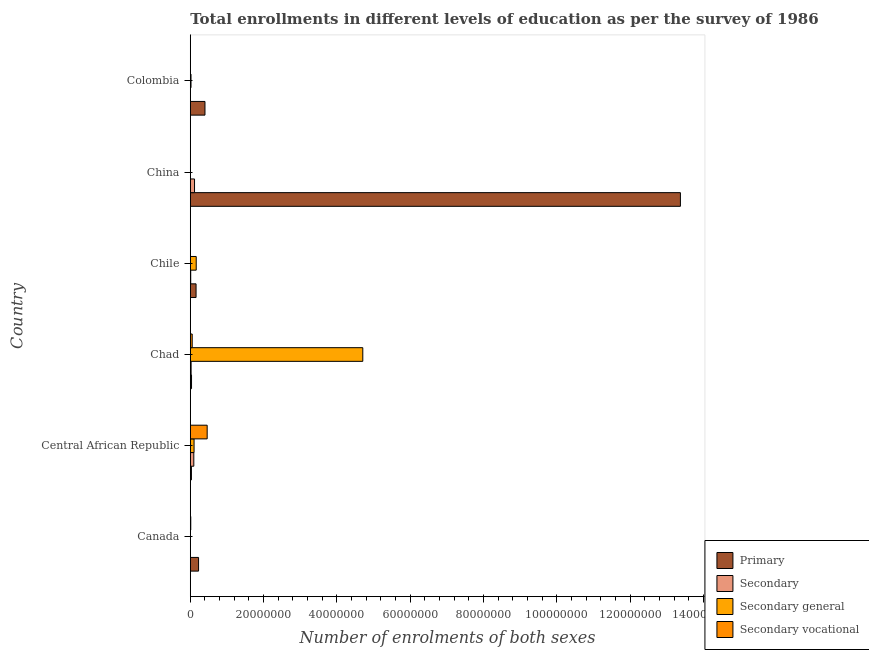How many groups of bars are there?
Keep it short and to the point. 6. Are the number of bars per tick equal to the number of legend labels?
Keep it short and to the point. Yes. How many bars are there on the 2nd tick from the top?
Provide a short and direct response. 4. What is the label of the 4th group of bars from the top?
Keep it short and to the point. Chad. What is the number of enrolments in primary education in Canada?
Make the answer very short. 2.25e+06. Across all countries, what is the maximum number of enrolments in secondary vocational education?
Your answer should be very brief. 4.60e+06. Across all countries, what is the minimum number of enrolments in secondary education?
Your answer should be compact. 2.11e+04. In which country was the number of enrolments in secondary general education maximum?
Keep it short and to the point. Chad. In which country was the number of enrolments in primary education minimum?
Offer a very short reply. Central African Republic. What is the total number of enrolments in secondary vocational education in the graph?
Ensure brevity in your answer.  5.30e+06. What is the difference between the number of enrolments in secondary vocational education in Chad and that in Chile?
Make the answer very short. 5.18e+05. What is the difference between the number of enrolments in secondary general education in Canada and the number of enrolments in secondary vocational education in Chad?
Provide a short and direct response. -4.62e+05. What is the average number of enrolments in secondary education per country?
Offer a terse response. 4.20e+05. What is the difference between the number of enrolments in secondary vocational education and number of enrolments in primary education in Canada?
Keep it short and to the point. -2.13e+06. In how many countries, is the number of enrolments in secondary vocational education greater than 48000000 ?
Offer a terse response. 0. What is the ratio of the number of enrolments in primary education in Canada to that in Chile?
Your answer should be very brief. 1.43. Is the difference between the number of enrolments in secondary education in China and Colombia greater than the difference between the number of enrolments in primary education in China and Colombia?
Provide a succinct answer. No. What is the difference between the highest and the second highest number of enrolments in secondary general education?
Ensure brevity in your answer.  4.54e+07. What is the difference between the highest and the lowest number of enrolments in secondary vocational education?
Your response must be concise. 4.60e+06. What does the 1st bar from the top in China represents?
Your answer should be compact. Secondary vocational. What does the 1st bar from the bottom in Colombia represents?
Your response must be concise. Primary. Is it the case that in every country, the sum of the number of enrolments in primary education and number of enrolments in secondary education is greater than the number of enrolments in secondary general education?
Your response must be concise. No. How many bars are there?
Offer a very short reply. 24. Are all the bars in the graph horizontal?
Offer a terse response. Yes. What is the difference between two consecutive major ticks on the X-axis?
Provide a succinct answer. 2.00e+07. Are the values on the major ticks of X-axis written in scientific E-notation?
Ensure brevity in your answer.  No. Does the graph contain any zero values?
Provide a short and direct response. No. Where does the legend appear in the graph?
Give a very brief answer. Bottom right. What is the title of the graph?
Ensure brevity in your answer.  Total enrollments in different levels of education as per the survey of 1986. Does "Argument" appear as one of the legend labels in the graph?
Your answer should be compact. No. What is the label or title of the X-axis?
Your answer should be compact. Number of enrolments of both sexes. What is the label or title of the Y-axis?
Offer a very short reply. Country. What is the Number of enrolments of both sexes of Primary in Canada?
Provide a short and direct response. 2.25e+06. What is the Number of enrolments of both sexes of Secondary in Canada?
Your response must be concise. 2.11e+04. What is the Number of enrolments of both sexes in Secondary general in Canada?
Your response must be concise. 5.69e+04. What is the Number of enrolments of both sexes in Secondary vocational in Canada?
Provide a succinct answer. 1.27e+05. What is the Number of enrolments of both sexes of Primary in Central African Republic?
Provide a succinct answer. 3.10e+05. What is the Number of enrolments of both sexes of Secondary in Central African Republic?
Ensure brevity in your answer.  9.60e+05. What is the Number of enrolments of both sexes in Secondary general in Central African Republic?
Your response must be concise. 1.03e+06. What is the Number of enrolments of both sexes in Secondary vocational in Central African Republic?
Offer a terse response. 4.60e+06. What is the Number of enrolments of both sexes of Primary in Chad?
Your answer should be compact. 3.38e+05. What is the Number of enrolments of both sexes of Secondary in Chad?
Ensure brevity in your answer.  2.23e+05. What is the Number of enrolments of both sexes in Secondary general in Chad?
Ensure brevity in your answer.  4.71e+07. What is the Number of enrolments of both sexes in Secondary vocational in Chad?
Provide a short and direct response. 5.19e+05. What is the Number of enrolments of both sexes of Primary in Chile?
Keep it short and to the point. 1.57e+06. What is the Number of enrolments of both sexes of Secondary in Chile?
Your response must be concise. 1.15e+05. What is the Number of enrolments of both sexes in Secondary general in Chile?
Give a very brief answer. 1.62e+06. What is the Number of enrolments of both sexes in Secondary vocational in Chile?
Provide a succinct answer. 515. What is the Number of enrolments of both sexes in Primary in China?
Ensure brevity in your answer.  1.34e+08. What is the Number of enrolments of both sexes in Secondary in China?
Provide a short and direct response. 1.16e+06. What is the Number of enrolments of both sexes in Secondary general in China?
Keep it short and to the point. 2.05e+04. What is the Number of enrolments of both sexes of Secondary vocational in China?
Provide a succinct answer. 2.51e+04. What is the Number of enrolments of both sexes in Primary in Colombia?
Offer a terse response. 4.00e+06. What is the Number of enrolments of both sexes of Secondary in Colombia?
Offer a terse response. 4.62e+04. What is the Number of enrolments of both sexes in Secondary general in Colombia?
Offer a very short reply. 1.97e+05. What is the Number of enrolments of both sexes of Secondary vocational in Colombia?
Keep it short and to the point. 2.60e+04. Across all countries, what is the maximum Number of enrolments of both sexes in Primary?
Offer a terse response. 1.34e+08. Across all countries, what is the maximum Number of enrolments of both sexes of Secondary?
Offer a very short reply. 1.16e+06. Across all countries, what is the maximum Number of enrolments of both sexes in Secondary general?
Your response must be concise. 4.71e+07. Across all countries, what is the maximum Number of enrolments of both sexes in Secondary vocational?
Your answer should be very brief. 4.60e+06. Across all countries, what is the minimum Number of enrolments of both sexes of Primary?
Keep it short and to the point. 3.10e+05. Across all countries, what is the minimum Number of enrolments of both sexes of Secondary?
Keep it short and to the point. 2.11e+04. Across all countries, what is the minimum Number of enrolments of both sexes of Secondary general?
Your answer should be compact. 2.05e+04. Across all countries, what is the minimum Number of enrolments of both sexes of Secondary vocational?
Keep it short and to the point. 515. What is the total Number of enrolments of both sexes of Primary in the graph?
Keep it short and to the point. 1.42e+08. What is the total Number of enrolments of both sexes in Secondary in the graph?
Make the answer very short. 2.52e+06. What is the total Number of enrolments of both sexes in Secondary general in the graph?
Provide a short and direct response. 5.00e+07. What is the total Number of enrolments of both sexes in Secondary vocational in the graph?
Ensure brevity in your answer.  5.30e+06. What is the difference between the Number of enrolments of both sexes in Primary in Canada and that in Central African Republic?
Make the answer very short. 1.95e+06. What is the difference between the Number of enrolments of both sexes of Secondary in Canada and that in Central African Republic?
Your answer should be compact. -9.39e+05. What is the difference between the Number of enrolments of both sexes in Secondary general in Canada and that in Central African Republic?
Keep it short and to the point. -9.69e+05. What is the difference between the Number of enrolments of both sexes in Secondary vocational in Canada and that in Central African Republic?
Give a very brief answer. -4.48e+06. What is the difference between the Number of enrolments of both sexes in Primary in Canada and that in Chad?
Provide a succinct answer. 1.92e+06. What is the difference between the Number of enrolments of both sexes in Secondary in Canada and that in Chad?
Make the answer very short. -2.02e+05. What is the difference between the Number of enrolments of both sexes in Secondary general in Canada and that in Chad?
Keep it short and to the point. -4.70e+07. What is the difference between the Number of enrolments of both sexes in Secondary vocational in Canada and that in Chad?
Make the answer very short. -3.92e+05. What is the difference between the Number of enrolments of both sexes of Primary in Canada and that in Chile?
Make the answer very short. 6.80e+05. What is the difference between the Number of enrolments of both sexes in Secondary in Canada and that in Chile?
Keep it short and to the point. -9.36e+04. What is the difference between the Number of enrolments of both sexes in Secondary general in Canada and that in Chile?
Your response must be concise. -1.56e+06. What is the difference between the Number of enrolments of both sexes in Secondary vocational in Canada and that in Chile?
Make the answer very short. 1.27e+05. What is the difference between the Number of enrolments of both sexes in Primary in Canada and that in China?
Ensure brevity in your answer.  -1.31e+08. What is the difference between the Number of enrolments of both sexes of Secondary in Canada and that in China?
Offer a very short reply. -1.14e+06. What is the difference between the Number of enrolments of both sexes in Secondary general in Canada and that in China?
Ensure brevity in your answer.  3.64e+04. What is the difference between the Number of enrolments of both sexes in Secondary vocational in Canada and that in China?
Offer a very short reply. 1.02e+05. What is the difference between the Number of enrolments of both sexes in Primary in Canada and that in Colombia?
Provide a short and direct response. -1.75e+06. What is the difference between the Number of enrolments of both sexes of Secondary in Canada and that in Colombia?
Offer a terse response. -2.51e+04. What is the difference between the Number of enrolments of both sexes of Secondary general in Canada and that in Colombia?
Offer a very short reply. -1.41e+05. What is the difference between the Number of enrolments of both sexes of Secondary vocational in Canada and that in Colombia?
Provide a succinct answer. 1.01e+05. What is the difference between the Number of enrolments of both sexes in Primary in Central African Republic and that in Chad?
Give a very brief answer. -2.80e+04. What is the difference between the Number of enrolments of both sexes of Secondary in Central African Republic and that in Chad?
Provide a short and direct response. 7.37e+05. What is the difference between the Number of enrolments of both sexes of Secondary general in Central African Republic and that in Chad?
Make the answer very short. -4.60e+07. What is the difference between the Number of enrolments of both sexes of Secondary vocational in Central African Republic and that in Chad?
Offer a terse response. 4.09e+06. What is the difference between the Number of enrolments of both sexes in Primary in Central African Republic and that in Chile?
Your response must be concise. -1.27e+06. What is the difference between the Number of enrolments of both sexes of Secondary in Central African Republic and that in Chile?
Provide a short and direct response. 8.45e+05. What is the difference between the Number of enrolments of both sexes in Secondary general in Central African Republic and that in Chile?
Provide a short and direct response. -5.91e+05. What is the difference between the Number of enrolments of both sexes of Secondary vocational in Central African Republic and that in Chile?
Your answer should be very brief. 4.60e+06. What is the difference between the Number of enrolments of both sexes of Primary in Central African Republic and that in China?
Offer a terse response. -1.33e+08. What is the difference between the Number of enrolments of both sexes of Secondary in Central African Republic and that in China?
Your response must be concise. -1.97e+05. What is the difference between the Number of enrolments of both sexes in Secondary general in Central African Republic and that in China?
Provide a succinct answer. 1.01e+06. What is the difference between the Number of enrolments of both sexes of Secondary vocational in Central African Republic and that in China?
Offer a terse response. 4.58e+06. What is the difference between the Number of enrolments of both sexes of Primary in Central African Republic and that in Colombia?
Provide a succinct answer. -3.69e+06. What is the difference between the Number of enrolments of both sexes in Secondary in Central African Republic and that in Colombia?
Provide a succinct answer. 9.14e+05. What is the difference between the Number of enrolments of both sexes of Secondary general in Central African Republic and that in Colombia?
Give a very brief answer. 8.29e+05. What is the difference between the Number of enrolments of both sexes in Secondary vocational in Central African Republic and that in Colombia?
Give a very brief answer. 4.58e+06. What is the difference between the Number of enrolments of both sexes of Primary in Chad and that in Chile?
Offer a very short reply. -1.24e+06. What is the difference between the Number of enrolments of both sexes in Secondary in Chad and that in Chile?
Your response must be concise. 1.08e+05. What is the difference between the Number of enrolments of both sexes of Secondary general in Chad and that in Chile?
Your response must be concise. 4.54e+07. What is the difference between the Number of enrolments of both sexes in Secondary vocational in Chad and that in Chile?
Offer a terse response. 5.18e+05. What is the difference between the Number of enrolments of both sexes in Primary in Chad and that in China?
Keep it short and to the point. -1.33e+08. What is the difference between the Number of enrolments of both sexes in Secondary in Chad and that in China?
Your response must be concise. -9.34e+05. What is the difference between the Number of enrolments of both sexes of Secondary general in Chad and that in China?
Your answer should be compact. 4.70e+07. What is the difference between the Number of enrolments of both sexes of Secondary vocational in Chad and that in China?
Provide a short and direct response. 4.94e+05. What is the difference between the Number of enrolments of both sexes in Primary in Chad and that in Colombia?
Your response must be concise. -3.66e+06. What is the difference between the Number of enrolments of both sexes of Secondary in Chad and that in Colombia?
Provide a short and direct response. 1.76e+05. What is the difference between the Number of enrolments of both sexes of Secondary general in Chad and that in Colombia?
Ensure brevity in your answer.  4.69e+07. What is the difference between the Number of enrolments of both sexes in Secondary vocational in Chad and that in Colombia?
Make the answer very short. 4.93e+05. What is the difference between the Number of enrolments of both sexes of Primary in Chile and that in China?
Make the answer very short. -1.32e+08. What is the difference between the Number of enrolments of both sexes of Secondary in Chile and that in China?
Offer a terse response. -1.04e+06. What is the difference between the Number of enrolments of both sexes of Secondary general in Chile and that in China?
Offer a terse response. 1.60e+06. What is the difference between the Number of enrolments of both sexes in Secondary vocational in Chile and that in China?
Your response must be concise. -2.46e+04. What is the difference between the Number of enrolments of both sexes of Primary in Chile and that in Colombia?
Give a very brief answer. -2.43e+06. What is the difference between the Number of enrolments of both sexes in Secondary in Chile and that in Colombia?
Provide a succinct answer. 6.85e+04. What is the difference between the Number of enrolments of both sexes in Secondary general in Chile and that in Colombia?
Your answer should be very brief. 1.42e+06. What is the difference between the Number of enrolments of both sexes of Secondary vocational in Chile and that in Colombia?
Keep it short and to the point. -2.55e+04. What is the difference between the Number of enrolments of both sexes of Primary in China and that in Colombia?
Ensure brevity in your answer.  1.30e+08. What is the difference between the Number of enrolments of both sexes of Secondary in China and that in Colombia?
Offer a terse response. 1.11e+06. What is the difference between the Number of enrolments of both sexes of Secondary general in China and that in Colombia?
Offer a terse response. -1.77e+05. What is the difference between the Number of enrolments of both sexes in Secondary vocational in China and that in Colombia?
Your answer should be compact. -850. What is the difference between the Number of enrolments of both sexes of Primary in Canada and the Number of enrolments of both sexes of Secondary in Central African Republic?
Provide a succinct answer. 1.29e+06. What is the difference between the Number of enrolments of both sexes of Primary in Canada and the Number of enrolments of both sexes of Secondary general in Central African Republic?
Provide a succinct answer. 1.23e+06. What is the difference between the Number of enrolments of both sexes of Primary in Canada and the Number of enrolments of both sexes of Secondary vocational in Central African Republic?
Your answer should be very brief. -2.35e+06. What is the difference between the Number of enrolments of both sexes of Secondary in Canada and the Number of enrolments of both sexes of Secondary general in Central African Republic?
Offer a very short reply. -1.01e+06. What is the difference between the Number of enrolments of both sexes in Secondary in Canada and the Number of enrolments of both sexes in Secondary vocational in Central African Republic?
Offer a very short reply. -4.58e+06. What is the difference between the Number of enrolments of both sexes of Secondary general in Canada and the Number of enrolments of both sexes of Secondary vocational in Central African Republic?
Offer a terse response. -4.55e+06. What is the difference between the Number of enrolments of both sexes in Primary in Canada and the Number of enrolments of both sexes in Secondary in Chad?
Offer a very short reply. 2.03e+06. What is the difference between the Number of enrolments of both sexes in Primary in Canada and the Number of enrolments of both sexes in Secondary general in Chad?
Ensure brevity in your answer.  -4.48e+07. What is the difference between the Number of enrolments of both sexes of Primary in Canada and the Number of enrolments of both sexes of Secondary vocational in Chad?
Give a very brief answer. 1.74e+06. What is the difference between the Number of enrolments of both sexes in Secondary in Canada and the Number of enrolments of both sexes in Secondary general in Chad?
Your response must be concise. -4.70e+07. What is the difference between the Number of enrolments of both sexes in Secondary in Canada and the Number of enrolments of both sexes in Secondary vocational in Chad?
Your answer should be very brief. -4.98e+05. What is the difference between the Number of enrolments of both sexes of Secondary general in Canada and the Number of enrolments of both sexes of Secondary vocational in Chad?
Your answer should be very brief. -4.62e+05. What is the difference between the Number of enrolments of both sexes of Primary in Canada and the Number of enrolments of both sexes of Secondary in Chile?
Offer a very short reply. 2.14e+06. What is the difference between the Number of enrolments of both sexes of Primary in Canada and the Number of enrolments of both sexes of Secondary general in Chile?
Your answer should be compact. 6.37e+05. What is the difference between the Number of enrolments of both sexes of Primary in Canada and the Number of enrolments of both sexes of Secondary vocational in Chile?
Provide a succinct answer. 2.25e+06. What is the difference between the Number of enrolments of both sexes in Secondary in Canada and the Number of enrolments of both sexes in Secondary general in Chile?
Your answer should be compact. -1.60e+06. What is the difference between the Number of enrolments of both sexes of Secondary in Canada and the Number of enrolments of both sexes of Secondary vocational in Chile?
Make the answer very short. 2.05e+04. What is the difference between the Number of enrolments of both sexes of Secondary general in Canada and the Number of enrolments of both sexes of Secondary vocational in Chile?
Your response must be concise. 5.64e+04. What is the difference between the Number of enrolments of both sexes of Primary in Canada and the Number of enrolments of both sexes of Secondary in China?
Offer a very short reply. 1.10e+06. What is the difference between the Number of enrolments of both sexes in Primary in Canada and the Number of enrolments of both sexes in Secondary general in China?
Give a very brief answer. 2.23e+06. What is the difference between the Number of enrolments of both sexes of Primary in Canada and the Number of enrolments of both sexes of Secondary vocational in China?
Offer a very short reply. 2.23e+06. What is the difference between the Number of enrolments of both sexes of Secondary in Canada and the Number of enrolments of both sexes of Secondary general in China?
Provide a short and direct response. 515. What is the difference between the Number of enrolments of both sexes in Secondary in Canada and the Number of enrolments of both sexes in Secondary vocational in China?
Provide a succinct answer. -4086. What is the difference between the Number of enrolments of both sexes in Secondary general in Canada and the Number of enrolments of both sexes in Secondary vocational in China?
Ensure brevity in your answer.  3.18e+04. What is the difference between the Number of enrolments of both sexes in Primary in Canada and the Number of enrolments of both sexes in Secondary in Colombia?
Provide a short and direct response. 2.21e+06. What is the difference between the Number of enrolments of both sexes of Primary in Canada and the Number of enrolments of both sexes of Secondary general in Colombia?
Your answer should be very brief. 2.06e+06. What is the difference between the Number of enrolments of both sexes of Primary in Canada and the Number of enrolments of both sexes of Secondary vocational in Colombia?
Your answer should be very brief. 2.23e+06. What is the difference between the Number of enrolments of both sexes in Secondary in Canada and the Number of enrolments of both sexes in Secondary general in Colombia?
Ensure brevity in your answer.  -1.76e+05. What is the difference between the Number of enrolments of both sexes of Secondary in Canada and the Number of enrolments of both sexes of Secondary vocational in Colombia?
Give a very brief answer. -4936. What is the difference between the Number of enrolments of both sexes in Secondary general in Canada and the Number of enrolments of both sexes in Secondary vocational in Colombia?
Your response must be concise. 3.09e+04. What is the difference between the Number of enrolments of both sexes in Primary in Central African Republic and the Number of enrolments of both sexes in Secondary in Chad?
Provide a succinct answer. 8.70e+04. What is the difference between the Number of enrolments of both sexes in Primary in Central African Republic and the Number of enrolments of both sexes in Secondary general in Chad?
Your answer should be compact. -4.67e+07. What is the difference between the Number of enrolments of both sexes in Primary in Central African Republic and the Number of enrolments of both sexes in Secondary vocational in Chad?
Ensure brevity in your answer.  -2.09e+05. What is the difference between the Number of enrolments of both sexes of Secondary in Central African Republic and the Number of enrolments of both sexes of Secondary general in Chad?
Provide a short and direct response. -4.61e+07. What is the difference between the Number of enrolments of both sexes of Secondary in Central African Republic and the Number of enrolments of both sexes of Secondary vocational in Chad?
Provide a succinct answer. 4.41e+05. What is the difference between the Number of enrolments of both sexes of Secondary general in Central African Republic and the Number of enrolments of both sexes of Secondary vocational in Chad?
Give a very brief answer. 5.07e+05. What is the difference between the Number of enrolments of both sexes of Primary in Central African Republic and the Number of enrolments of both sexes of Secondary in Chile?
Give a very brief answer. 1.95e+05. What is the difference between the Number of enrolments of both sexes of Primary in Central African Republic and the Number of enrolments of both sexes of Secondary general in Chile?
Make the answer very short. -1.31e+06. What is the difference between the Number of enrolments of both sexes of Primary in Central African Republic and the Number of enrolments of both sexes of Secondary vocational in Chile?
Your response must be concise. 3.09e+05. What is the difference between the Number of enrolments of both sexes of Secondary in Central African Republic and the Number of enrolments of both sexes of Secondary general in Chile?
Your response must be concise. -6.57e+05. What is the difference between the Number of enrolments of both sexes in Secondary in Central African Republic and the Number of enrolments of both sexes in Secondary vocational in Chile?
Give a very brief answer. 9.59e+05. What is the difference between the Number of enrolments of both sexes in Secondary general in Central African Republic and the Number of enrolments of both sexes in Secondary vocational in Chile?
Make the answer very short. 1.03e+06. What is the difference between the Number of enrolments of both sexes of Primary in Central African Republic and the Number of enrolments of both sexes of Secondary in China?
Provide a short and direct response. -8.47e+05. What is the difference between the Number of enrolments of both sexes of Primary in Central African Republic and the Number of enrolments of both sexes of Secondary general in China?
Your answer should be very brief. 2.89e+05. What is the difference between the Number of enrolments of both sexes of Primary in Central African Republic and the Number of enrolments of both sexes of Secondary vocational in China?
Ensure brevity in your answer.  2.85e+05. What is the difference between the Number of enrolments of both sexes of Secondary in Central African Republic and the Number of enrolments of both sexes of Secondary general in China?
Keep it short and to the point. 9.39e+05. What is the difference between the Number of enrolments of both sexes of Secondary in Central African Republic and the Number of enrolments of both sexes of Secondary vocational in China?
Your answer should be compact. 9.35e+05. What is the difference between the Number of enrolments of both sexes in Secondary general in Central African Republic and the Number of enrolments of both sexes in Secondary vocational in China?
Provide a short and direct response. 1.00e+06. What is the difference between the Number of enrolments of both sexes of Primary in Central African Republic and the Number of enrolments of both sexes of Secondary in Colombia?
Offer a terse response. 2.63e+05. What is the difference between the Number of enrolments of both sexes in Primary in Central African Republic and the Number of enrolments of both sexes in Secondary general in Colombia?
Keep it short and to the point. 1.12e+05. What is the difference between the Number of enrolments of both sexes of Primary in Central African Republic and the Number of enrolments of both sexes of Secondary vocational in Colombia?
Your answer should be very brief. 2.84e+05. What is the difference between the Number of enrolments of both sexes of Secondary in Central African Republic and the Number of enrolments of both sexes of Secondary general in Colombia?
Your response must be concise. 7.62e+05. What is the difference between the Number of enrolments of both sexes of Secondary in Central African Republic and the Number of enrolments of both sexes of Secondary vocational in Colombia?
Offer a terse response. 9.34e+05. What is the difference between the Number of enrolments of both sexes of Secondary general in Central African Republic and the Number of enrolments of both sexes of Secondary vocational in Colombia?
Make the answer very short. 1.00e+06. What is the difference between the Number of enrolments of both sexes of Primary in Chad and the Number of enrolments of both sexes of Secondary in Chile?
Your answer should be compact. 2.23e+05. What is the difference between the Number of enrolments of both sexes in Primary in Chad and the Number of enrolments of both sexes in Secondary general in Chile?
Keep it short and to the point. -1.28e+06. What is the difference between the Number of enrolments of both sexes of Primary in Chad and the Number of enrolments of both sexes of Secondary vocational in Chile?
Offer a terse response. 3.37e+05. What is the difference between the Number of enrolments of both sexes in Secondary in Chad and the Number of enrolments of both sexes in Secondary general in Chile?
Your answer should be very brief. -1.39e+06. What is the difference between the Number of enrolments of both sexes of Secondary in Chad and the Number of enrolments of both sexes of Secondary vocational in Chile?
Your answer should be very brief. 2.22e+05. What is the difference between the Number of enrolments of both sexes of Secondary general in Chad and the Number of enrolments of both sexes of Secondary vocational in Chile?
Make the answer very short. 4.71e+07. What is the difference between the Number of enrolments of both sexes in Primary in Chad and the Number of enrolments of both sexes in Secondary in China?
Keep it short and to the point. -8.19e+05. What is the difference between the Number of enrolments of both sexes of Primary in Chad and the Number of enrolments of both sexes of Secondary general in China?
Provide a succinct answer. 3.17e+05. What is the difference between the Number of enrolments of both sexes of Primary in Chad and the Number of enrolments of both sexes of Secondary vocational in China?
Your answer should be compact. 3.12e+05. What is the difference between the Number of enrolments of both sexes of Secondary in Chad and the Number of enrolments of both sexes of Secondary general in China?
Ensure brevity in your answer.  2.02e+05. What is the difference between the Number of enrolments of both sexes in Secondary in Chad and the Number of enrolments of both sexes in Secondary vocational in China?
Your response must be concise. 1.97e+05. What is the difference between the Number of enrolments of both sexes in Secondary general in Chad and the Number of enrolments of both sexes in Secondary vocational in China?
Give a very brief answer. 4.70e+07. What is the difference between the Number of enrolments of both sexes in Primary in Chad and the Number of enrolments of both sexes in Secondary in Colombia?
Your response must be concise. 2.91e+05. What is the difference between the Number of enrolments of both sexes of Primary in Chad and the Number of enrolments of both sexes of Secondary general in Colombia?
Keep it short and to the point. 1.40e+05. What is the difference between the Number of enrolments of both sexes of Primary in Chad and the Number of enrolments of both sexes of Secondary vocational in Colombia?
Provide a succinct answer. 3.12e+05. What is the difference between the Number of enrolments of both sexes of Secondary in Chad and the Number of enrolments of both sexes of Secondary general in Colombia?
Provide a succinct answer. 2.51e+04. What is the difference between the Number of enrolments of both sexes of Secondary in Chad and the Number of enrolments of both sexes of Secondary vocational in Colombia?
Your answer should be very brief. 1.97e+05. What is the difference between the Number of enrolments of both sexes of Secondary general in Chad and the Number of enrolments of both sexes of Secondary vocational in Colombia?
Give a very brief answer. 4.70e+07. What is the difference between the Number of enrolments of both sexes of Primary in Chile and the Number of enrolments of both sexes of Secondary in China?
Provide a short and direct response. 4.18e+05. What is the difference between the Number of enrolments of both sexes of Primary in Chile and the Number of enrolments of both sexes of Secondary general in China?
Offer a very short reply. 1.55e+06. What is the difference between the Number of enrolments of both sexes of Primary in Chile and the Number of enrolments of both sexes of Secondary vocational in China?
Your answer should be very brief. 1.55e+06. What is the difference between the Number of enrolments of both sexes of Secondary in Chile and the Number of enrolments of both sexes of Secondary general in China?
Provide a succinct answer. 9.41e+04. What is the difference between the Number of enrolments of both sexes of Secondary in Chile and the Number of enrolments of both sexes of Secondary vocational in China?
Provide a short and direct response. 8.95e+04. What is the difference between the Number of enrolments of both sexes of Secondary general in Chile and the Number of enrolments of both sexes of Secondary vocational in China?
Your response must be concise. 1.59e+06. What is the difference between the Number of enrolments of both sexes of Primary in Chile and the Number of enrolments of both sexes of Secondary in Colombia?
Offer a very short reply. 1.53e+06. What is the difference between the Number of enrolments of both sexes in Primary in Chile and the Number of enrolments of both sexes in Secondary general in Colombia?
Offer a very short reply. 1.38e+06. What is the difference between the Number of enrolments of both sexes in Primary in Chile and the Number of enrolments of both sexes in Secondary vocational in Colombia?
Make the answer very short. 1.55e+06. What is the difference between the Number of enrolments of both sexes in Secondary in Chile and the Number of enrolments of both sexes in Secondary general in Colombia?
Keep it short and to the point. -8.28e+04. What is the difference between the Number of enrolments of both sexes in Secondary in Chile and the Number of enrolments of both sexes in Secondary vocational in Colombia?
Ensure brevity in your answer.  8.87e+04. What is the difference between the Number of enrolments of both sexes in Secondary general in Chile and the Number of enrolments of both sexes in Secondary vocational in Colombia?
Your answer should be compact. 1.59e+06. What is the difference between the Number of enrolments of both sexes of Primary in China and the Number of enrolments of both sexes of Secondary in Colombia?
Provide a short and direct response. 1.34e+08. What is the difference between the Number of enrolments of both sexes in Primary in China and the Number of enrolments of both sexes in Secondary general in Colombia?
Provide a succinct answer. 1.34e+08. What is the difference between the Number of enrolments of both sexes in Primary in China and the Number of enrolments of both sexes in Secondary vocational in Colombia?
Give a very brief answer. 1.34e+08. What is the difference between the Number of enrolments of both sexes of Secondary in China and the Number of enrolments of both sexes of Secondary general in Colombia?
Give a very brief answer. 9.59e+05. What is the difference between the Number of enrolments of both sexes in Secondary in China and the Number of enrolments of both sexes in Secondary vocational in Colombia?
Your response must be concise. 1.13e+06. What is the difference between the Number of enrolments of both sexes in Secondary general in China and the Number of enrolments of both sexes in Secondary vocational in Colombia?
Your answer should be very brief. -5451. What is the average Number of enrolments of both sexes of Primary per country?
Your answer should be very brief. 2.37e+07. What is the average Number of enrolments of both sexes in Secondary per country?
Keep it short and to the point. 4.20e+05. What is the average Number of enrolments of both sexes in Secondary general per country?
Provide a succinct answer. 8.33e+06. What is the average Number of enrolments of both sexes in Secondary vocational per country?
Provide a succinct answer. 8.84e+05. What is the difference between the Number of enrolments of both sexes in Primary and Number of enrolments of both sexes in Secondary in Canada?
Offer a very short reply. 2.23e+06. What is the difference between the Number of enrolments of both sexes of Primary and Number of enrolments of both sexes of Secondary general in Canada?
Offer a very short reply. 2.20e+06. What is the difference between the Number of enrolments of both sexes in Primary and Number of enrolments of both sexes in Secondary vocational in Canada?
Your answer should be compact. 2.13e+06. What is the difference between the Number of enrolments of both sexes of Secondary and Number of enrolments of both sexes of Secondary general in Canada?
Offer a terse response. -3.59e+04. What is the difference between the Number of enrolments of both sexes in Secondary and Number of enrolments of both sexes in Secondary vocational in Canada?
Give a very brief answer. -1.06e+05. What is the difference between the Number of enrolments of both sexes of Secondary general and Number of enrolments of both sexes of Secondary vocational in Canada?
Provide a succinct answer. -7.01e+04. What is the difference between the Number of enrolments of both sexes of Primary and Number of enrolments of both sexes of Secondary in Central African Republic?
Make the answer very short. -6.50e+05. What is the difference between the Number of enrolments of both sexes of Primary and Number of enrolments of both sexes of Secondary general in Central African Republic?
Your answer should be very brief. -7.17e+05. What is the difference between the Number of enrolments of both sexes in Primary and Number of enrolments of both sexes in Secondary vocational in Central African Republic?
Your answer should be very brief. -4.29e+06. What is the difference between the Number of enrolments of both sexes in Secondary and Number of enrolments of both sexes in Secondary general in Central African Republic?
Your response must be concise. -6.63e+04. What is the difference between the Number of enrolments of both sexes in Secondary and Number of enrolments of both sexes in Secondary vocational in Central African Republic?
Provide a succinct answer. -3.64e+06. What is the difference between the Number of enrolments of both sexes of Secondary general and Number of enrolments of both sexes of Secondary vocational in Central African Republic?
Make the answer very short. -3.58e+06. What is the difference between the Number of enrolments of both sexes of Primary and Number of enrolments of both sexes of Secondary in Chad?
Your answer should be compact. 1.15e+05. What is the difference between the Number of enrolments of both sexes of Primary and Number of enrolments of both sexes of Secondary general in Chad?
Your answer should be very brief. -4.67e+07. What is the difference between the Number of enrolments of both sexes in Primary and Number of enrolments of both sexes in Secondary vocational in Chad?
Offer a terse response. -1.81e+05. What is the difference between the Number of enrolments of both sexes in Secondary and Number of enrolments of both sexes in Secondary general in Chad?
Your answer should be very brief. -4.68e+07. What is the difference between the Number of enrolments of both sexes in Secondary and Number of enrolments of both sexes in Secondary vocational in Chad?
Make the answer very short. -2.96e+05. What is the difference between the Number of enrolments of both sexes in Secondary general and Number of enrolments of both sexes in Secondary vocational in Chad?
Provide a succinct answer. 4.65e+07. What is the difference between the Number of enrolments of both sexes in Primary and Number of enrolments of both sexes in Secondary in Chile?
Your answer should be very brief. 1.46e+06. What is the difference between the Number of enrolments of both sexes of Primary and Number of enrolments of both sexes of Secondary general in Chile?
Keep it short and to the point. -4.25e+04. What is the difference between the Number of enrolments of both sexes of Primary and Number of enrolments of both sexes of Secondary vocational in Chile?
Make the answer very short. 1.57e+06. What is the difference between the Number of enrolments of both sexes of Secondary and Number of enrolments of both sexes of Secondary general in Chile?
Keep it short and to the point. -1.50e+06. What is the difference between the Number of enrolments of both sexes of Secondary and Number of enrolments of both sexes of Secondary vocational in Chile?
Offer a terse response. 1.14e+05. What is the difference between the Number of enrolments of both sexes in Secondary general and Number of enrolments of both sexes in Secondary vocational in Chile?
Your response must be concise. 1.62e+06. What is the difference between the Number of enrolments of both sexes in Primary and Number of enrolments of both sexes in Secondary in China?
Provide a succinct answer. 1.33e+08. What is the difference between the Number of enrolments of both sexes of Primary and Number of enrolments of both sexes of Secondary general in China?
Your answer should be very brief. 1.34e+08. What is the difference between the Number of enrolments of both sexes of Primary and Number of enrolments of both sexes of Secondary vocational in China?
Your answer should be compact. 1.34e+08. What is the difference between the Number of enrolments of both sexes in Secondary and Number of enrolments of both sexes in Secondary general in China?
Give a very brief answer. 1.14e+06. What is the difference between the Number of enrolments of both sexes in Secondary and Number of enrolments of both sexes in Secondary vocational in China?
Provide a succinct answer. 1.13e+06. What is the difference between the Number of enrolments of both sexes of Secondary general and Number of enrolments of both sexes of Secondary vocational in China?
Give a very brief answer. -4601. What is the difference between the Number of enrolments of both sexes of Primary and Number of enrolments of both sexes of Secondary in Colombia?
Make the answer very short. 3.96e+06. What is the difference between the Number of enrolments of both sexes in Primary and Number of enrolments of both sexes in Secondary general in Colombia?
Provide a succinct answer. 3.81e+06. What is the difference between the Number of enrolments of both sexes in Primary and Number of enrolments of both sexes in Secondary vocational in Colombia?
Keep it short and to the point. 3.98e+06. What is the difference between the Number of enrolments of both sexes in Secondary and Number of enrolments of both sexes in Secondary general in Colombia?
Provide a short and direct response. -1.51e+05. What is the difference between the Number of enrolments of both sexes of Secondary and Number of enrolments of both sexes of Secondary vocational in Colombia?
Your answer should be very brief. 2.02e+04. What is the difference between the Number of enrolments of both sexes of Secondary general and Number of enrolments of both sexes of Secondary vocational in Colombia?
Ensure brevity in your answer.  1.71e+05. What is the ratio of the Number of enrolments of both sexes in Primary in Canada to that in Central African Republic?
Your response must be concise. 7.28. What is the ratio of the Number of enrolments of both sexes in Secondary in Canada to that in Central African Republic?
Provide a succinct answer. 0.02. What is the ratio of the Number of enrolments of both sexes of Secondary general in Canada to that in Central African Republic?
Your response must be concise. 0.06. What is the ratio of the Number of enrolments of both sexes in Secondary vocational in Canada to that in Central African Republic?
Your response must be concise. 0.03. What is the ratio of the Number of enrolments of both sexes of Primary in Canada to that in Chad?
Your response must be concise. 6.68. What is the ratio of the Number of enrolments of both sexes in Secondary in Canada to that in Chad?
Ensure brevity in your answer.  0.09. What is the ratio of the Number of enrolments of both sexes of Secondary general in Canada to that in Chad?
Offer a very short reply. 0. What is the ratio of the Number of enrolments of both sexes in Secondary vocational in Canada to that in Chad?
Make the answer very short. 0.24. What is the ratio of the Number of enrolments of both sexes of Primary in Canada to that in Chile?
Ensure brevity in your answer.  1.43. What is the ratio of the Number of enrolments of both sexes in Secondary in Canada to that in Chile?
Your response must be concise. 0.18. What is the ratio of the Number of enrolments of both sexes in Secondary general in Canada to that in Chile?
Provide a short and direct response. 0.04. What is the ratio of the Number of enrolments of both sexes in Secondary vocational in Canada to that in Chile?
Ensure brevity in your answer.  246.72. What is the ratio of the Number of enrolments of both sexes in Primary in Canada to that in China?
Make the answer very short. 0.02. What is the ratio of the Number of enrolments of both sexes of Secondary in Canada to that in China?
Offer a very short reply. 0.02. What is the ratio of the Number of enrolments of both sexes in Secondary general in Canada to that in China?
Your response must be concise. 2.77. What is the ratio of the Number of enrolments of both sexes in Secondary vocational in Canada to that in China?
Give a very brief answer. 5.05. What is the ratio of the Number of enrolments of both sexes in Primary in Canada to that in Colombia?
Keep it short and to the point. 0.56. What is the ratio of the Number of enrolments of both sexes of Secondary in Canada to that in Colombia?
Keep it short and to the point. 0.46. What is the ratio of the Number of enrolments of both sexes of Secondary general in Canada to that in Colombia?
Ensure brevity in your answer.  0.29. What is the ratio of the Number of enrolments of both sexes of Secondary vocational in Canada to that in Colombia?
Offer a very short reply. 4.89. What is the ratio of the Number of enrolments of both sexes in Primary in Central African Republic to that in Chad?
Make the answer very short. 0.92. What is the ratio of the Number of enrolments of both sexes of Secondary in Central African Republic to that in Chad?
Ensure brevity in your answer.  4.31. What is the ratio of the Number of enrolments of both sexes of Secondary general in Central African Republic to that in Chad?
Ensure brevity in your answer.  0.02. What is the ratio of the Number of enrolments of both sexes of Secondary vocational in Central African Republic to that in Chad?
Give a very brief answer. 8.87. What is the ratio of the Number of enrolments of both sexes of Primary in Central African Republic to that in Chile?
Offer a terse response. 0.2. What is the ratio of the Number of enrolments of both sexes of Secondary in Central African Republic to that in Chile?
Your answer should be compact. 8.37. What is the ratio of the Number of enrolments of both sexes of Secondary general in Central African Republic to that in Chile?
Your response must be concise. 0.63. What is the ratio of the Number of enrolments of both sexes in Secondary vocational in Central African Republic to that in Chile?
Your response must be concise. 8940.19. What is the ratio of the Number of enrolments of both sexes of Primary in Central African Republic to that in China?
Provide a succinct answer. 0. What is the ratio of the Number of enrolments of both sexes of Secondary in Central African Republic to that in China?
Give a very brief answer. 0.83. What is the ratio of the Number of enrolments of both sexes of Secondary general in Central African Republic to that in China?
Ensure brevity in your answer.  49.96. What is the ratio of the Number of enrolments of both sexes in Secondary vocational in Central African Republic to that in China?
Your answer should be compact. 183.13. What is the ratio of the Number of enrolments of both sexes in Primary in Central African Republic to that in Colombia?
Provide a succinct answer. 0.08. What is the ratio of the Number of enrolments of both sexes in Secondary in Central African Republic to that in Colombia?
Ensure brevity in your answer.  20.8. What is the ratio of the Number of enrolments of both sexes in Secondary general in Central African Republic to that in Colombia?
Provide a succinct answer. 5.2. What is the ratio of the Number of enrolments of both sexes of Secondary vocational in Central African Republic to that in Colombia?
Keep it short and to the point. 177.14. What is the ratio of the Number of enrolments of both sexes of Primary in Chad to that in Chile?
Ensure brevity in your answer.  0.21. What is the ratio of the Number of enrolments of both sexes of Secondary in Chad to that in Chile?
Provide a succinct answer. 1.94. What is the ratio of the Number of enrolments of both sexes of Secondary general in Chad to that in Chile?
Give a very brief answer. 29.1. What is the ratio of the Number of enrolments of both sexes in Secondary vocational in Chad to that in Chile?
Your answer should be very brief. 1007.48. What is the ratio of the Number of enrolments of both sexes in Primary in Chad to that in China?
Provide a succinct answer. 0. What is the ratio of the Number of enrolments of both sexes in Secondary in Chad to that in China?
Your answer should be very brief. 0.19. What is the ratio of the Number of enrolments of both sexes of Secondary general in Chad to that in China?
Your answer should be compact. 2291.01. What is the ratio of the Number of enrolments of both sexes in Secondary vocational in Chad to that in China?
Your answer should be very brief. 20.64. What is the ratio of the Number of enrolments of both sexes in Primary in Chad to that in Colombia?
Make the answer very short. 0.08. What is the ratio of the Number of enrolments of both sexes in Secondary in Chad to that in Colombia?
Provide a succinct answer. 4.82. What is the ratio of the Number of enrolments of both sexes of Secondary general in Chad to that in Colombia?
Give a very brief answer. 238.29. What is the ratio of the Number of enrolments of both sexes of Secondary vocational in Chad to that in Colombia?
Keep it short and to the point. 19.96. What is the ratio of the Number of enrolments of both sexes in Primary in Chile to that in China?
Give a very brief answer. 0.01. What is the ratio of the Number of enrolments of both sexes in Secondary in Chile to that in China?
Your answer should be compact. 0.1. What is the ratio of the Number of enrolments of both sexes in Secondary general in Chile to that in China?
Provide a short and direct response. 78.74. What is the ratio of the Number of enrolments of both sexes in Secondary vocational in Chile to that in China?
Provide a short and direct response. 0.02. What is the ratio of the Number of enrolments of both sexes of Primary in Chile to that in Colombia?
Provide a succinct answer. 0.39. What is the ratio of the Number of enrolments of both sexes of Secondary in Chile to that in Colombia?
Offer a very short reply. 2.48. What is the ratio of the Number of enrolments of both sexes of Secondary general in Chile to that in Colombia?
Offer a very short reply. 8.19. What is the ratio of the Number of enrolments of both sexes of Secondary vocational in Chile to that in Colombia?
Provide a succinct answer. 0.02. What is the ratio of the Number of enrolments of both sexes of Primary in China to that in Colombia?
Provide a short and direct response. 33.4. What is the ratio of the Number of enrolments of both sexes of Secondary in China to that in Colombia?
Your response must be concise. 25.06. What is the ratio of the Number of enrolments of both sexes of Secondary general in China to that in Colombia?
Keep it short and to the point. 0.1. What is the ratio of the Number of enrolments of both sexes in Secondary vocational in China to that in Colombia?
Your answer should be compact. 0.97. What is the difference between the highest and the second highest Number of enrolments of both sexes of Primary?
Keep it short and to the point. 1.30e+08. What is the difference between the highest and the second highest Number of enrolments of both sexes of Secondary?
Keep it short and to the point. 1.97e+05. What is the difference between the highest and the second highest Number of enrolments of both sexes of Secondary general?
Provide a succinct answer. 4.54e+07. What is the difference between the highest and the second highest Number of enrolments of both sexes of Secondary vocational?
Keep it short and to the point. 4.09e+06. What is the difference between the highest and the lowest Number of enrolments of both sexes in Primary?
Provide a short and direct response. 1.33e+08. What is the difference between the highest and the lowest Number of enrolments of both sexes of Secondary?
Give a very brief answer. 1.14e+06. What is the difference between the highest and the lowest Number of enrolments of both sexes of Secondary general?
Provide a succinct answer. 4.70e+07. What is the difference between the highest and the lowest Number of enrolments of both sexes of Secondary vocational?
Ensure brevity in your answer.  4.60e+06. 